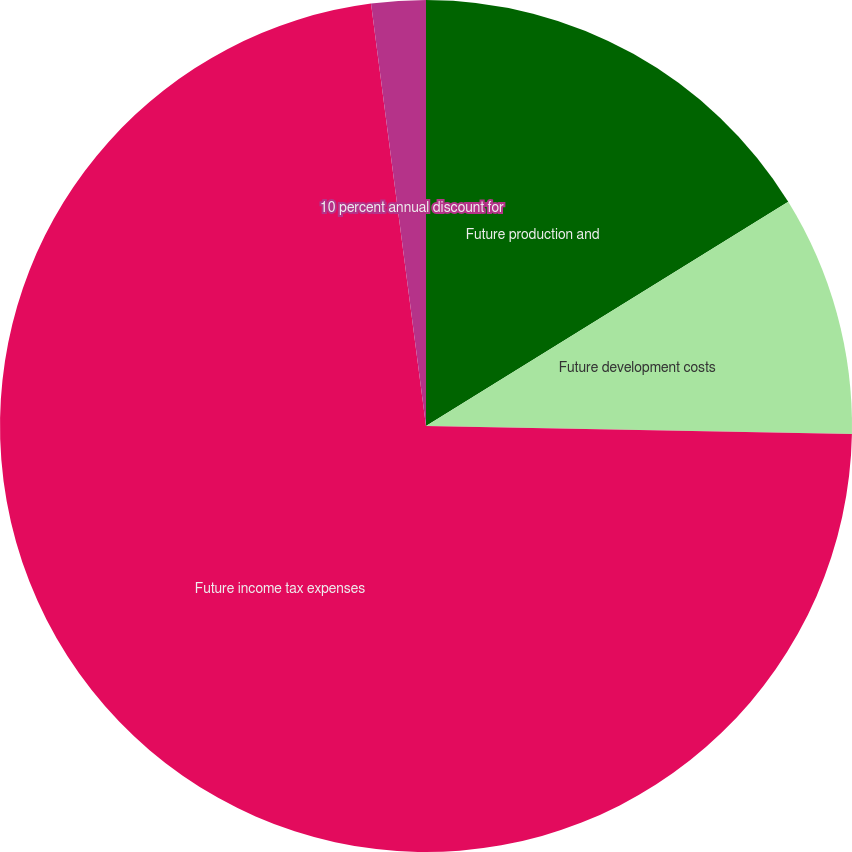Convert chart to OTSL. <chart><loc_0><loc_0><loc_500><loc_500><pie_chart><fcel>Future production and<fcel>Future development costs<fcel>Future income tax expenses<fcel>10 percent annual discount for<nl><fcel>16.18%<fcel>9.12%<fcel>72.64%<fcel>2.06%<nl></chart> 